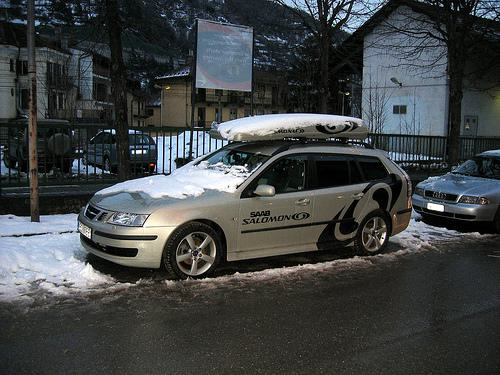How many cars would there be in the image after a car was removed from the image? Assuming two cars are initially visible in the image, if one car is removed, there would then be one car remaining in the view. 